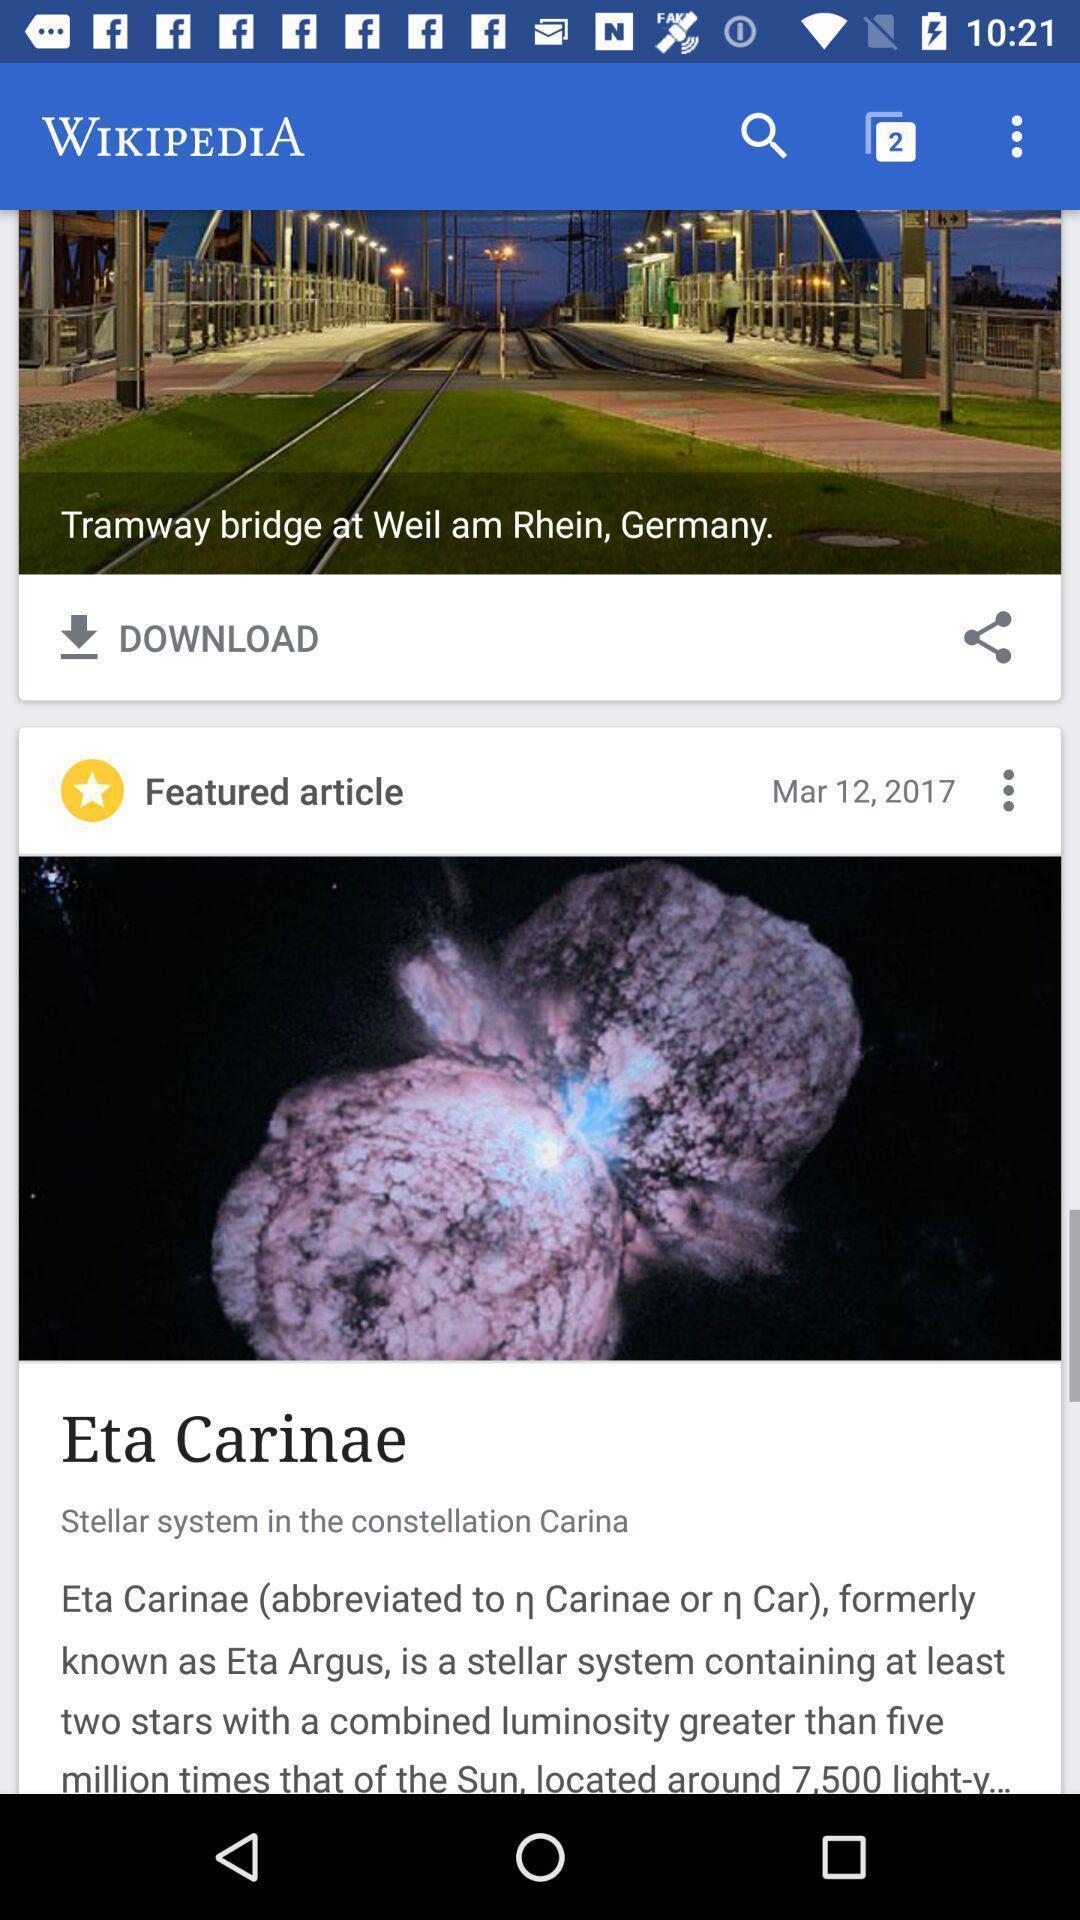Tell me about the visual elements in this screen capture. Screen displaying the news page with articles. 